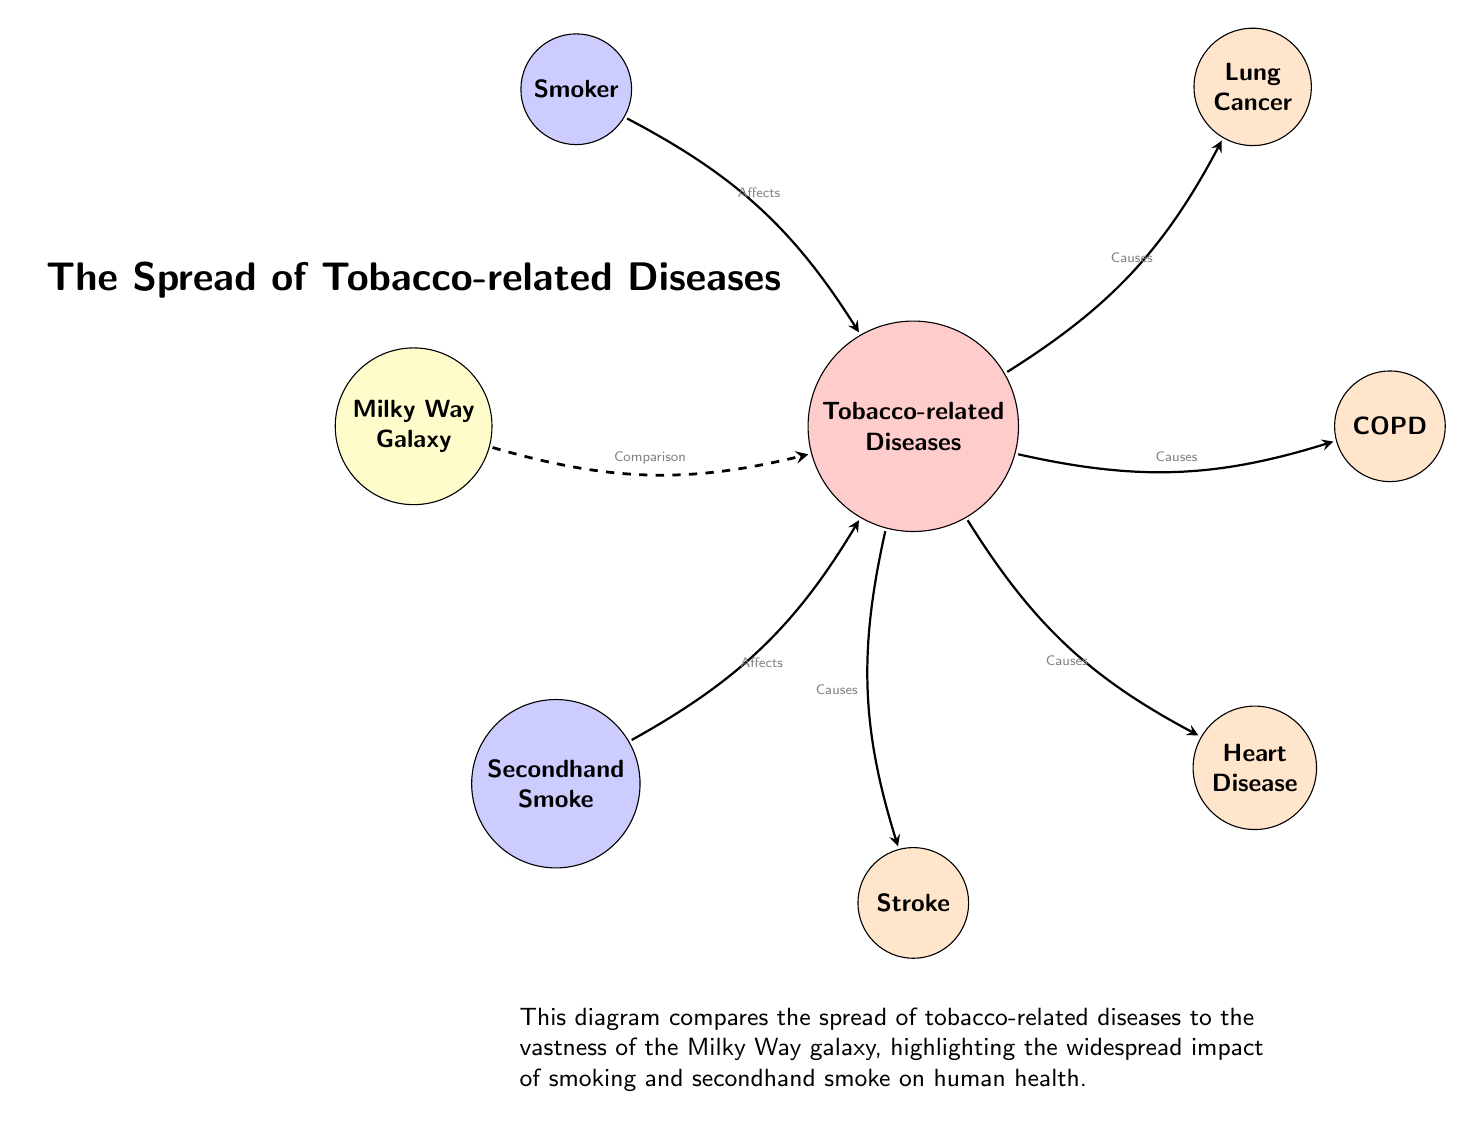What is the main subject of the diagram? The diagram centers around the comparison of the Milky Way Galaxy to Tobacco-related Diseases, suggesting a broad and impactful relation. It's depicted clearly in the title and the central nodes.
Answer: Tobacco-related Diseases How many diseases are shown in the diagram? The diagram illustrates four specific tobacco-related diseases: Lung Cancer, COPD, Heart Disease, and Stroke. By counting the nodes directly related to diseases, we arrive at this number.
Answer: 4 What relation does the Milky Way Galaxy have to Tobacco-related Diseases? The diagram indicates a dashed line labeled "Comparison," which connects the Milky Way Galaxy node to the Tobacco-related Diseases node, highlighting a comparison of significance or scale.
Answer: Comparison Which type of smoke is shown to affect Tobacco-related Diseases? The diagram features two sources of smoke that affect tobacco-related diseases: "Smoker" and "Secondhand Smoke." This is shown by arrows indicating influence leading to the Tobacco-related Diseases node.
Answer: Smoker and Secondhand Smoke What disease is directly connected to COPD? The diagram features a directed edge from the Tobacco-related Diseases node to the COPD node, indicating that COPD is a direct consequence of tobacco use, as confirmed by the "Causes" label on the arrow.
Answer: COPD Which disease is located directly above Right of Tobacco-related Diseases? Lung Cancer is positioned directly above and to the right of the Tobacco-related Diseases node within the diagram, as indicated by its placement near that node.
Answer: Lung Cancer What does the diagram suggest about the impact of secondhand smoke? The arrow leading from Secondhand Smoke to Tobacco-related Diseases shows that it has a causative or contributory role in tobacco-related diseases, as suggested by the "Affects" label on that edge.
Answer: Causes What is shown to be the relationship between Smoker and Tobacco-related Diseases? The diagram shows an arrow from the Smoker node to the Tobacco-related Diseases node, indicating that being a smoker directly contributes to the development of those diseases. This is defined by the "Affects" label on the edge.
Answer: Affects What element is used to illustrate the diseases in the diagram? Each disease is depicted in a node styled as a circle filled with an orange shade in the diagram, differentiating it from other elements and emphasizing their significance.
Answer: Circle Which color signifies the Milky Way Galaxy in the diagram? The Milky Way Galaxy node in the diagram is filled with a yellow shade, which is easily identifiable and distinguishes it from other nodes.
Answer: Yellow 